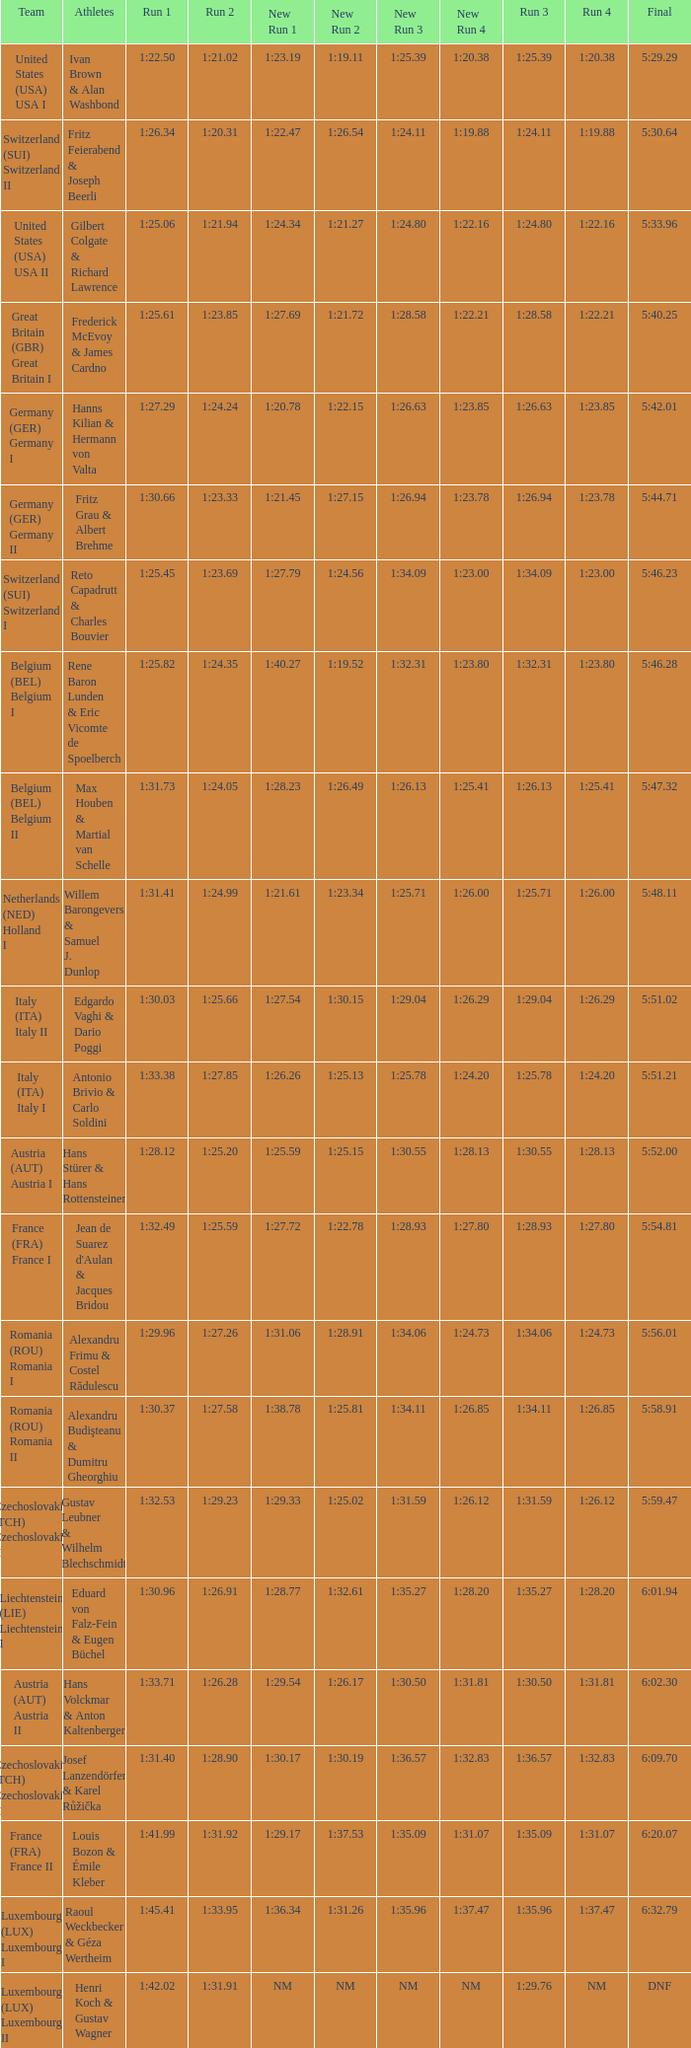Which Run 4 has a Run 1 of 1:25.82? 1:23.80. 